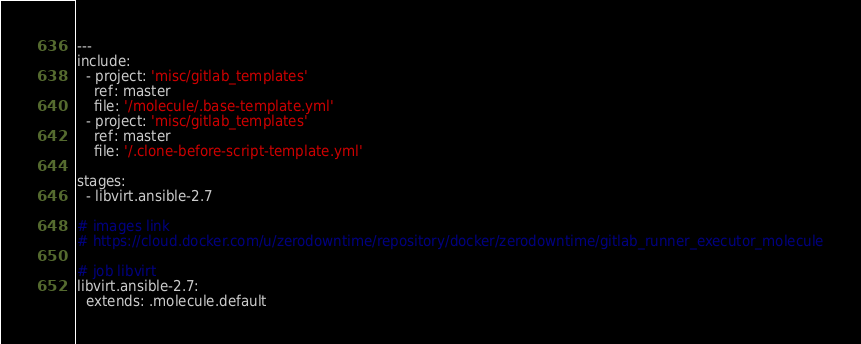<code> <loc_0><loc_0><loc_500><loc_500><_YAML_>---
include:
  - project: 'misc/gitlab_templates'
    ref: master
    file: '/molecule/.base-template.yml'
  - project: 'misc/gitlab_templates'
    ref: master
    file: '/.clone-before-script-template.yml'

stages:
  - libvirt.ansible-2.7

# images link
# https://cloud.docker.com/u/zerodowntime/repository/docker/zerodowntime/gitlab_runner_executor_molecule

# job libvirt
libvirt.ansible-2.7:
  extends: .molecule.default</code> 